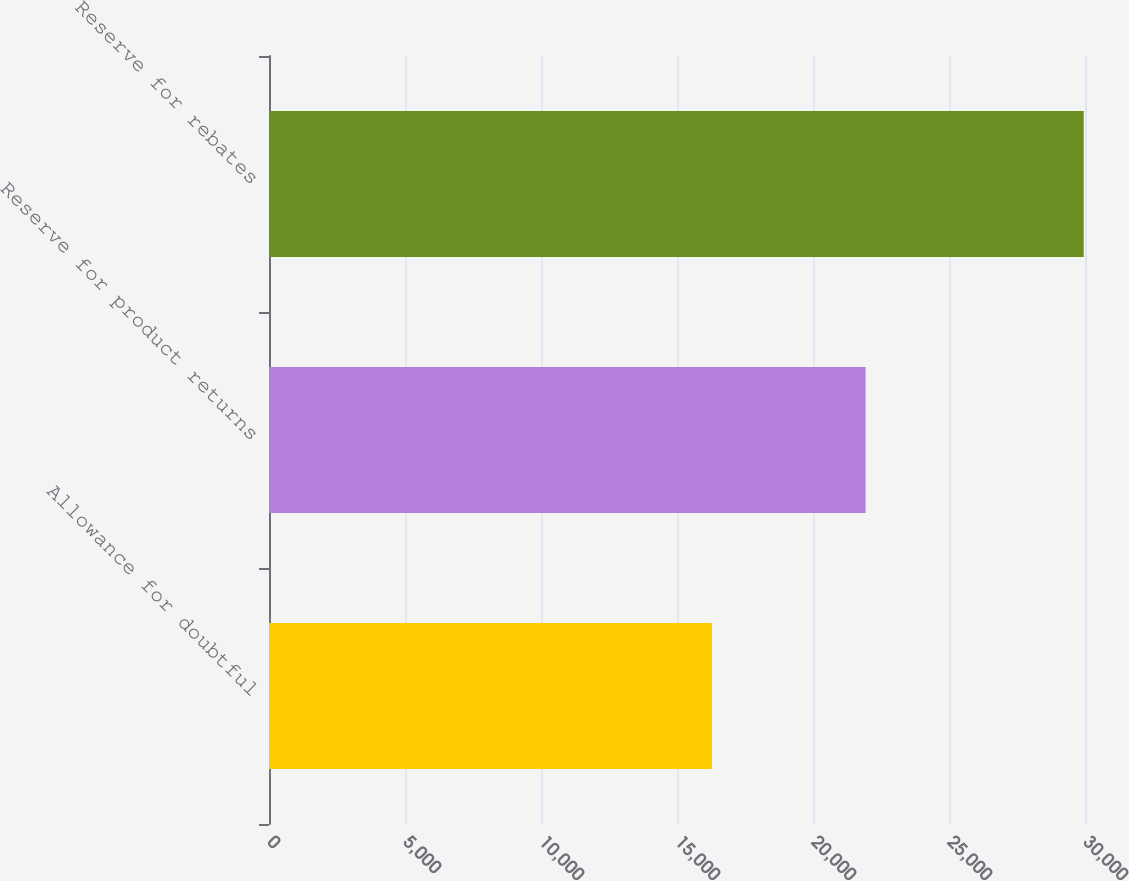Convert chart. <chart><loc_0><loc_0><loc_500><loc_500><bar_chart><fcel>Allowance for doubtful<fcel>Reserve for product returns<fcel>Reserve for rebates<nl><fcel>16285<fcel>21932<fcel>29952<nl></chart> 